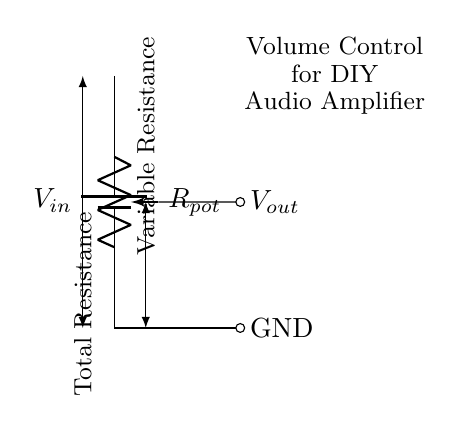What is the input voltage represented in the circuit? The input voltage in the circuit is denoted as \(V_{in}\) at the top of the battery symbol. This label indicates the source voltage providing power to the circuit.
Answer: Vin What type of component is used for volume control in this circuit? The component used for volume control is a potentiometer, indicated by the label \(R_{pot}\). A potentiometer is a type of variable resistor used to adjust levels, such as volume in audio applications.
Answer: Potentiometer What is the output voltage taken from in this circuit? The output voltage \(V_{out}\) is taken from the wiper of the potentiometer, which is connected directly to the output line labeled as \(V_{out}\). This point allows variable voltage based on the position of the potentiometer wiper.
Answer: Wiper of the potentiometer How does the total resistance in this circuit relate to the potentiometer? The total resistance in this circuit is provided by the potentiometer, denoted as \(R_{pot}\). The wiper allows for variable resistance, altering the proportion of total resistance that appears in the output based on its setting.
Answer: Rpot What happens to the output voltage if the potentiometer is adjusted to its minimum resistance? If the potentiometer is adjusted to its minimum resistance (effectively setting it to zero), the output voltage \(V_{out}\) will be at its maximum value, which is equal to the input voltage \(V_{in}\), because the entire voltage will drop across the load.
Answer: Vin If a signal is inputted into this circuit, how is the output signal affected by the potentiometer’s position? The output signal \(V_{out}\) is affected by the position of the potentiometer since it changes the resistance that divides the voltage. As the wiper moves, it alters the fraction of the input voltage that appears at the output, thus adjusting the audio volume.
Answer: Changes as per potentiometer position 